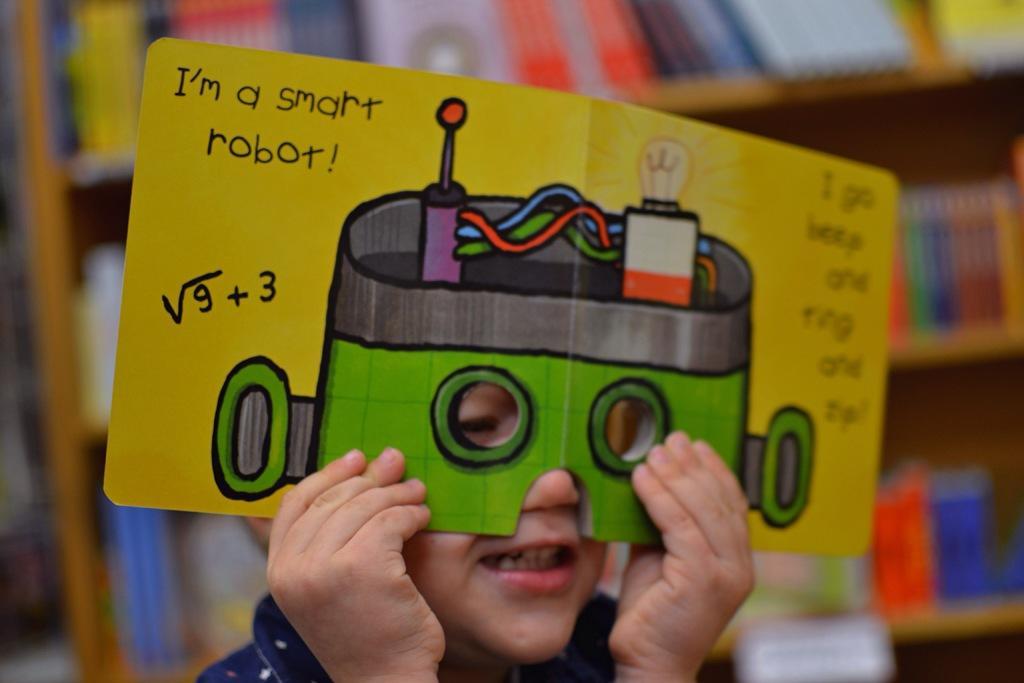Can you describe this image briefly? In the image there is a boy, he is wearing a mask which has some paintings and texts on it. He is holding the mask with his both hands and the background of the boy is blur. 